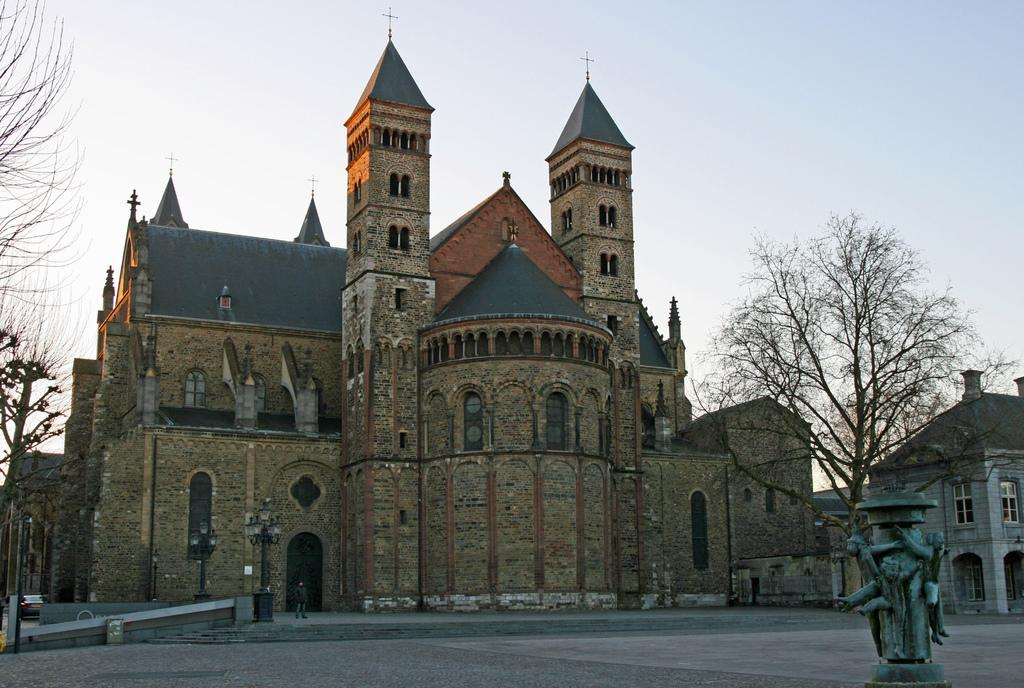What type of structure is in the image? There is a fort in the image. What is located in front of the fort? There is a tree in front of the fort. What can be seen on the left side of the image? A vehicle is visible on the road on the left side of the image. What is present on the right side of the image? There is a statue visible on the right side of the image. What type of hook is hanging from the tree in the image? There is no hook present in the image; it features a tree in front of a fort. 